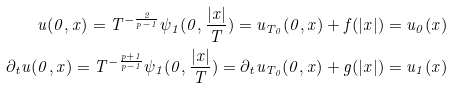Convert formula to latex. <formula><loc_0><loc_0><loc_500><loc_500>u ( 0 , x ) = T ^ { - \frac { 2 } { p - 1 } } \psi _ { 1 } ( 0 , \frac { | x | } { T } ) = u _ { T _ { 0 } } ( 0 , x ) + f ( | x | ) = u _ { 0 } ( x ) \\ \partial _ { t } u ( 0 , x ) = T ^ { - \frac { p + 1 } { p - 1 } } \psi _ { 1 } ( 0 , \frac { | x | } { T } ) = \partial _ { t } u _ { T _ { 0 } } ( 0 , x ) + g ( | x | ) = u _ { 1 } ( x )</formula> 